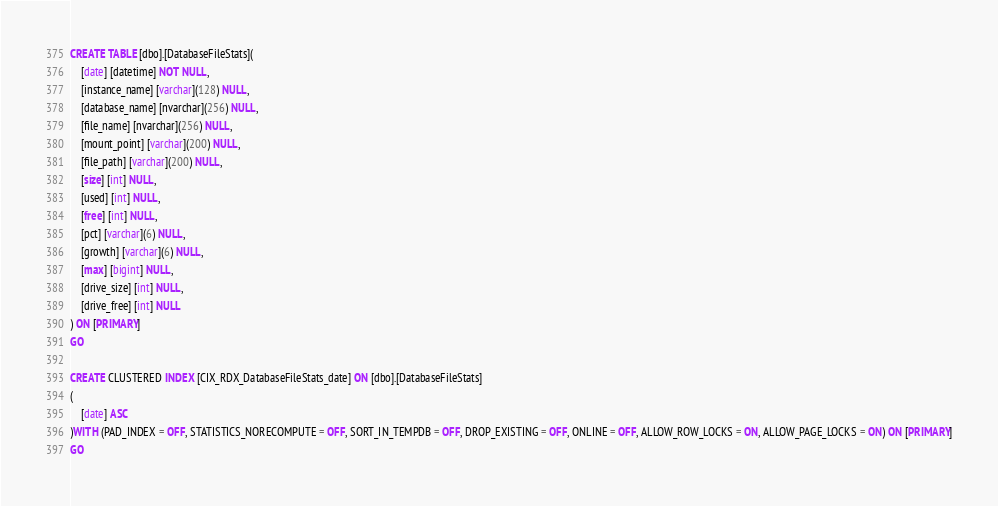<code> <loc_0><loc_0><loc_500><loc_500><_SQL_>
CREATE TABLE [dbo].[DatabaseFileStats](
	[date] [datetime] NOT NULL,
	[instance_name] [varchar](128) NULL,
	[database_name] [nvarchar](256) NULL,
	[file_name] [nvarchar](256) NULL,
	[mount_point] [varchar](200) NULL,
	[file_path] [varchar](200) NULL,
	[size] [int] NULL,
	[used] [int] NULL,
	[free] [int] NULL,
	[pct] [varchar](6) NULL,
	[growth] [varchar](6) NULL,
	[max] [bigint] NULL,
	[drive_size] [int] NULL,
	[drive_free] [int] NULL
) ON [PRIMARY]
GO

CREATE CLUSTERED INDEX [CIX_RDX_DatabaseFileStats_date] ON [dbo].[DatabaseFileStats]
(
	[date] ASC
)WITH (PAD_INDEX = OFF, STATISTICS_NORECOMPUTE = OFF, SORT_IN_TEMPDB = OFF, DROP_EXISTING = OFF, ONLINE = OFF, ALLOW_ROW_LOCKS = ON, ALLOW_PAGE_LOCKS = ON) ON [PRIMARY]
GO


</code> 